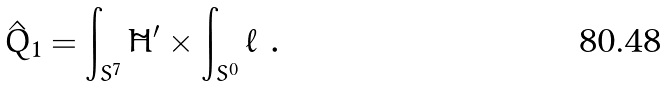Convert formula to latex. <formula><loc_0><loc_0><loc_500><loc_500>\hat { Q } _ { 1 } = \int _ { S ^ { 7 } } \tilde { H } ^ { \prime } \times \int _ { S ^ { 0 } } \ell \ .</formula> 